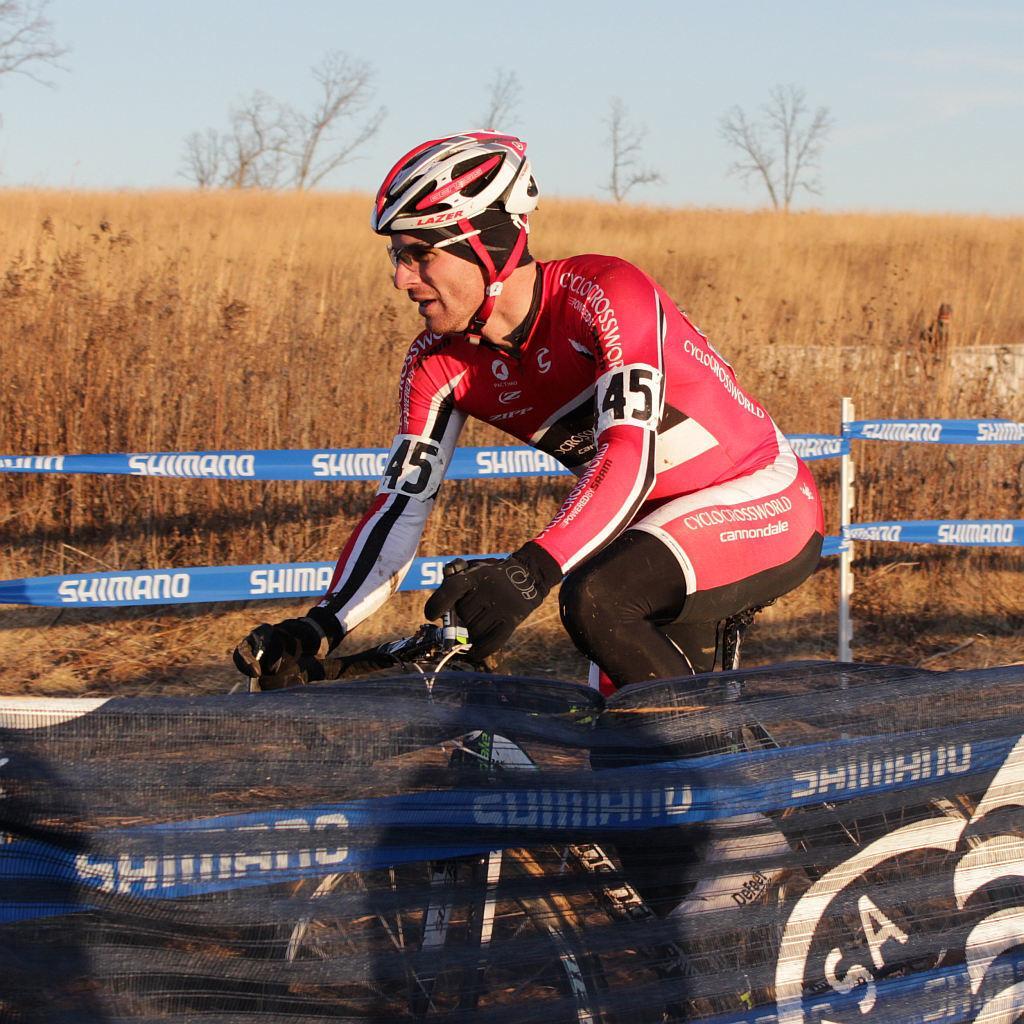Could you give a brief overview of what you see in this image? In the picture we can see a man riding a bicycle and the man is with sportswear and a helmet and beside him we can see a railing and behind it, we can see dried grass plants and far from it we can see the dried trees and sky. 